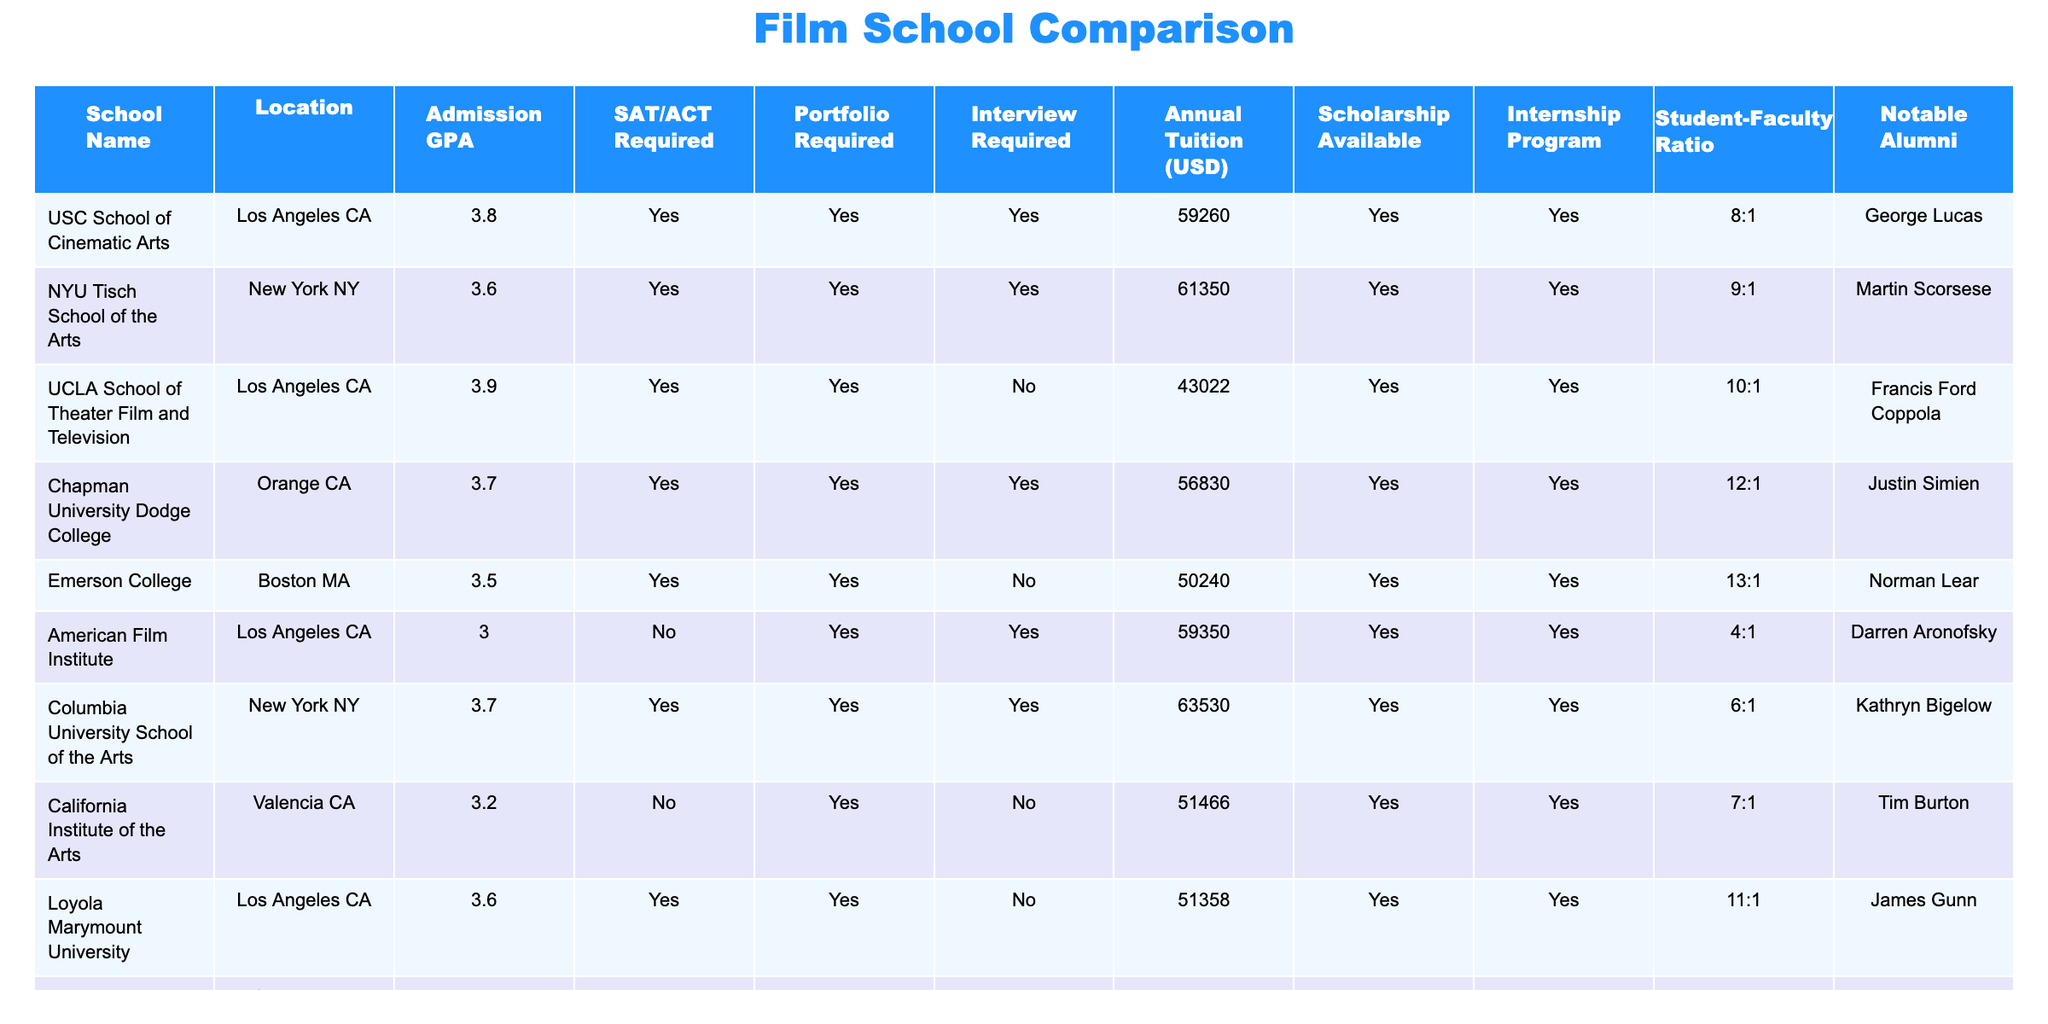What is the admission GPA requirement for UCLA School of Theater Film and Television? According to the table, the admission GPA requirement for UCLA School of Theater Film and Television is listed as 3.9.
Answer: 3.9 Which school has the highest annual tuition? The table shows that Columbia University School of the Arts has the highest annual tuition at $63,530.
Answer: $63,530 Is a portfolio required for admission to the American Film Institute? The table indicates that a portfolio is required for admission to the American Film Institute, with a corresponding "Yes" in the portfolio required column.
Answer: Yes What is the student-faculty ratio at USC School of Cinematic Arts? The table lists the student-faculty ratio at USC School of Cinematic Arts as 8:1.
Answer: 8:1 How many schools have an internship program based on the data provided? There are 8 schools listed in the table and all of them have an internship program, as indicated by the "Yes" values in the internship program column.
Answer: 8 What is the difference in annual tuition between NYU Tisch School of the Arts and Emerson College? The annual tuition for NYU Tisch School of the Arts is $61,350 and for Emerson College, it is $50,240. The difference is $61,350 - $50,240 = $11,110.
Answer: $11,110 Which school is located in Florida? The only school located in Florida, according to the table, is Ringling College of Art and Design.
Answer: Ringling College of Art and Design What is the average admission GPA for schools that require portfolios? The admission GPAs for schools that require portfolios are 3.8 (USC), 3.6 (NYU), 3.9 (UCLA), 3.7 (Chapman), 3.7 (Columbia), and 3.6 (Loyola). Summing these gives 22.3, and dividing by 6 gives an average of 22.3 / 6 = 3.72.
Answer: 3.72 Which notable alumni is associated with Loyola Marymount University? The table indicates that James Gunn is the notable alumni associated with Loyola Marymount University.
Answer: James Gunn Is there a school on the list that does not require an SAT or ACT score? Yes, the American Film Institute does not require an SAT or ACT score, as indicated by the "No" in the SAT/ACT required column.
Answer: Yes What is the total annual tuition for the three schools with the lowest tuition costs? The three lowest tuition costs are for Ringling College of Art and Design ($46,930), UCLA ($43,022), and Emerson College ($50,240). Adding these gives $46,930 + $43,022 + $50,240 = $140,192.
Answer: $140,192 